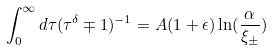<formula> <loc_0><loc_0><loc_500><loc_500>\int _ { 0 } ^ { \infty } d \tau ( \tau ^ { \delta } \mp 1 ) ^ { - 1 } = A ( 1 + \epsilon ) \ln ( \frac { \alpha } { \xi _ { \pm } } )</formula> 